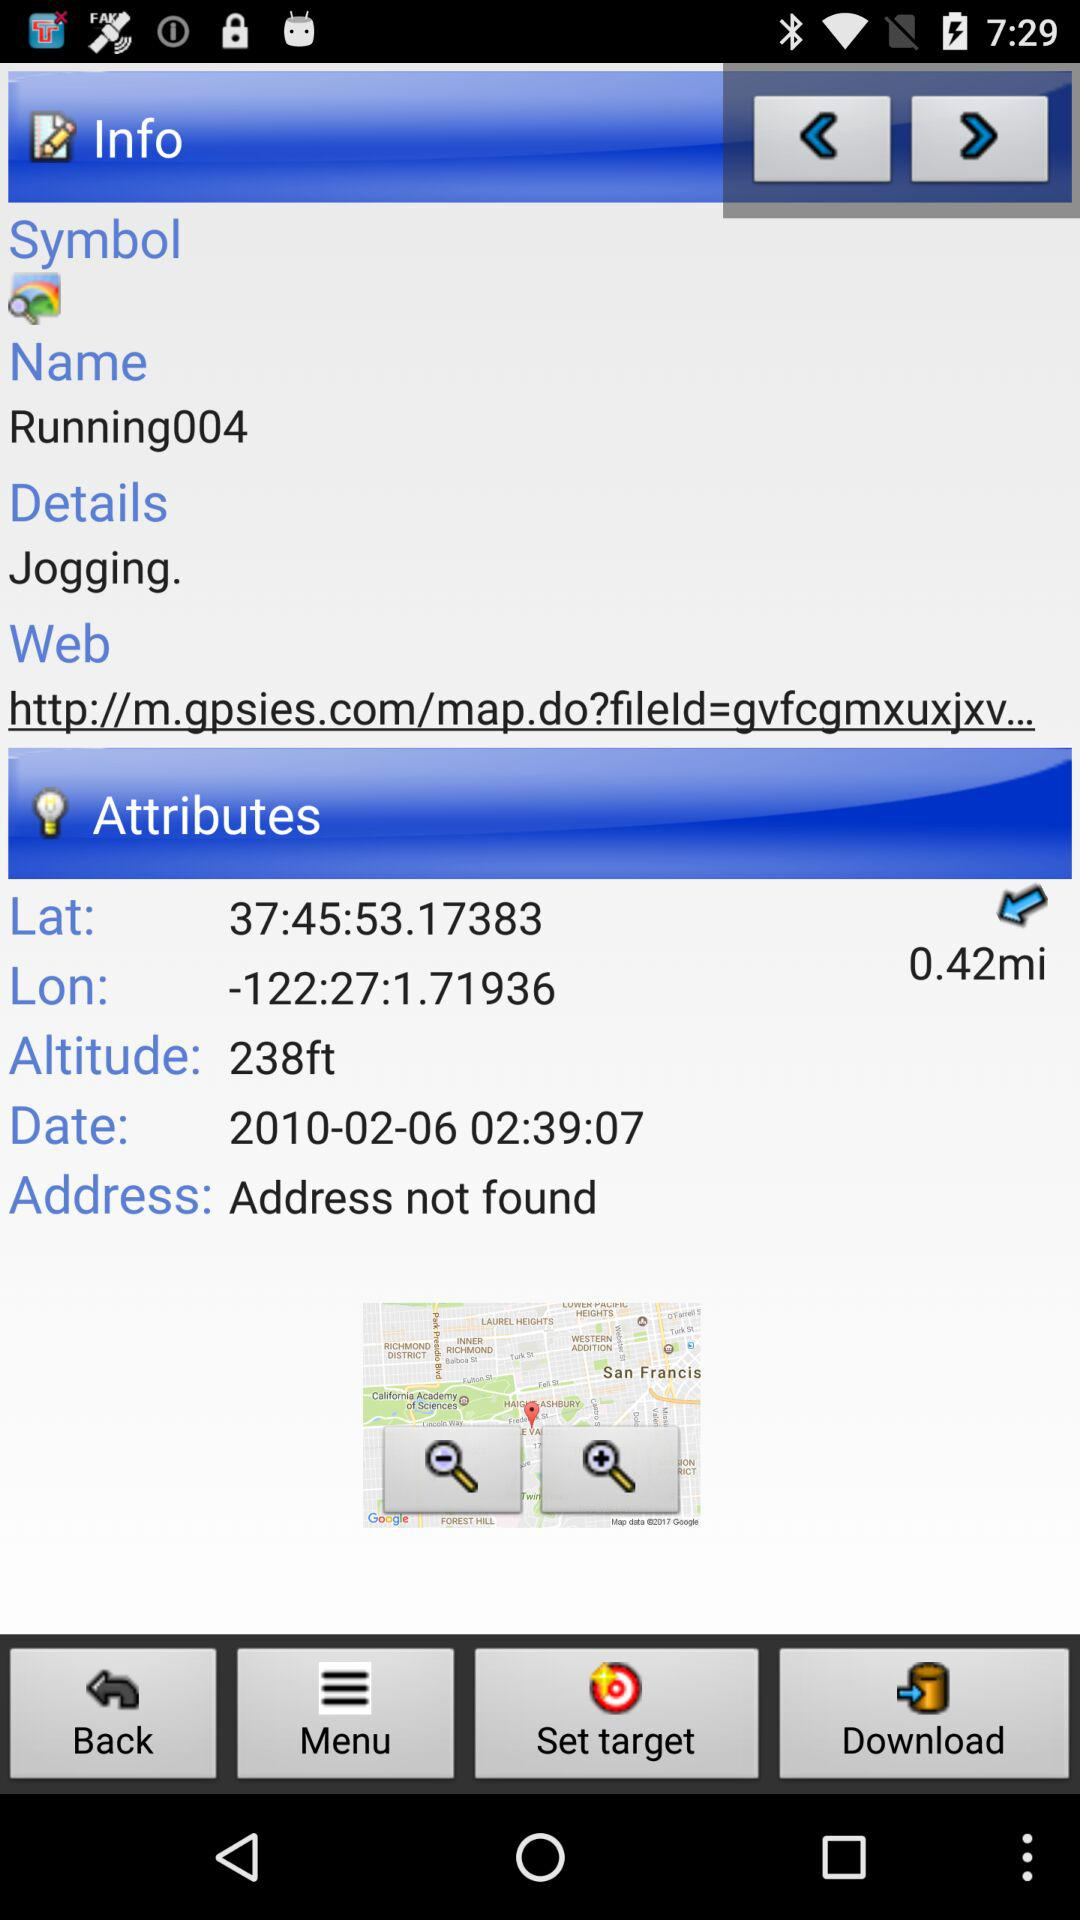What's the web address? The web address is "http://m.gpsies.com/map.do?fileld=gvfcgmxuxjxv...". 